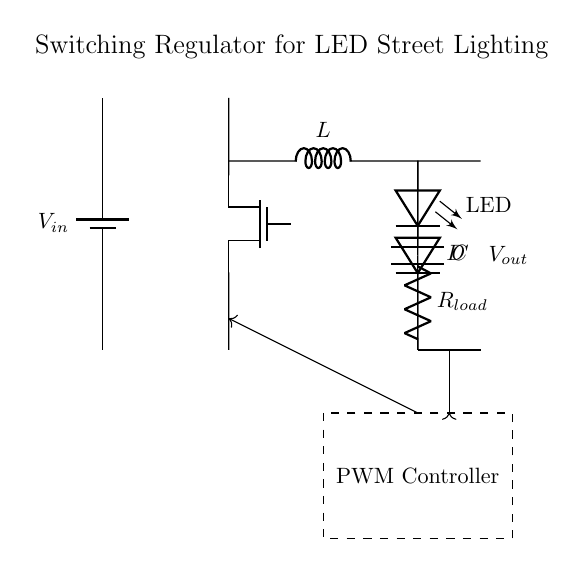What is the input voltage of this circuit? The input voltage is indicated by the label near the battery symbol in the circuit diagram, which is marked as V_in.
Answer: V_in What component is used for switching in this regulator circuit? The switching mechanism is achieved using a Tnmos component, as indicated in the circuit.
Answer: Tnmos What is the purpose of the inductor in this circuit? The inductor, labeled L, is part of the energy storage process in the switching regulator, allowing for the conversion and regulation of voltage.
Answer: Energy storage What type of load is connected to this circuit? The load connected in the circuit is an LED, which is visually represented and labeled as LED.
Answer: LED How does the PWM controller interact with the switching element? The PWM controller, located in the dashed rectangle, sends signals to the Tnmos switch to control the on/off states, thus regulating voltage and current flow.
Answer: Controls switching What does the capacitor in this circuit do? The capacitor, labeled C, smooths out the voltage fluctuations by storing and releasing energy, providing a stable output voltage to the load.
Answer: Smooths voltage Why is a diode included in this switching regulator? The diode, labeled D, ensures current flows in the correct direction during the switching process and prevents backflow, which is crucial for maintaining efficiency in the regulator.
Answer: Prevents backflow 